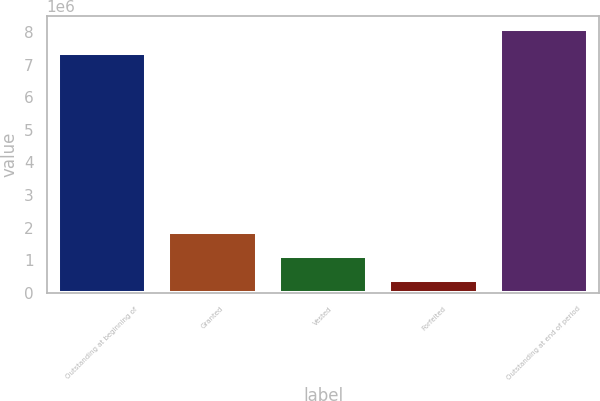<chart> <loc_0><loc_0><loc_500><loc_500><bar_chart><fcel>Outstanding at beginning of<fcel>Granted<fcel>Vested<fcel>Forfeited<fcel>Outstanding at end of period<nl><fcel>7.37329e+06<fcel>1.84811e+06<fcel>1.12348e+06<fcel>398859<fcel>8.09792e+06<nl></chart> 